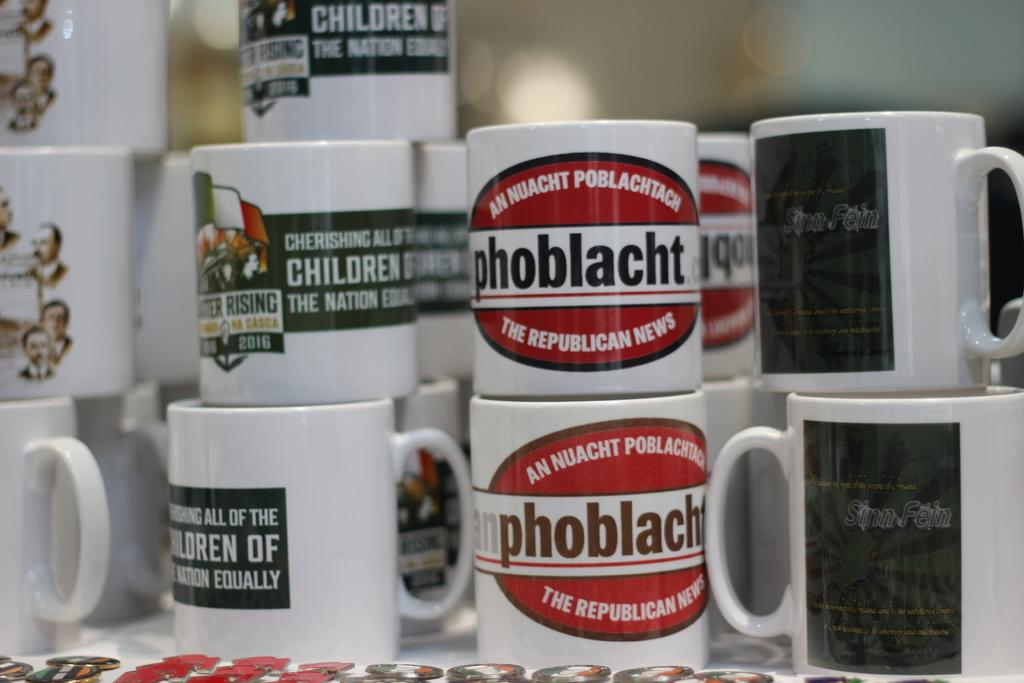<image>
Summarize the visual content of the image. collection  of mugs with some saying Cherishing all of the Children 